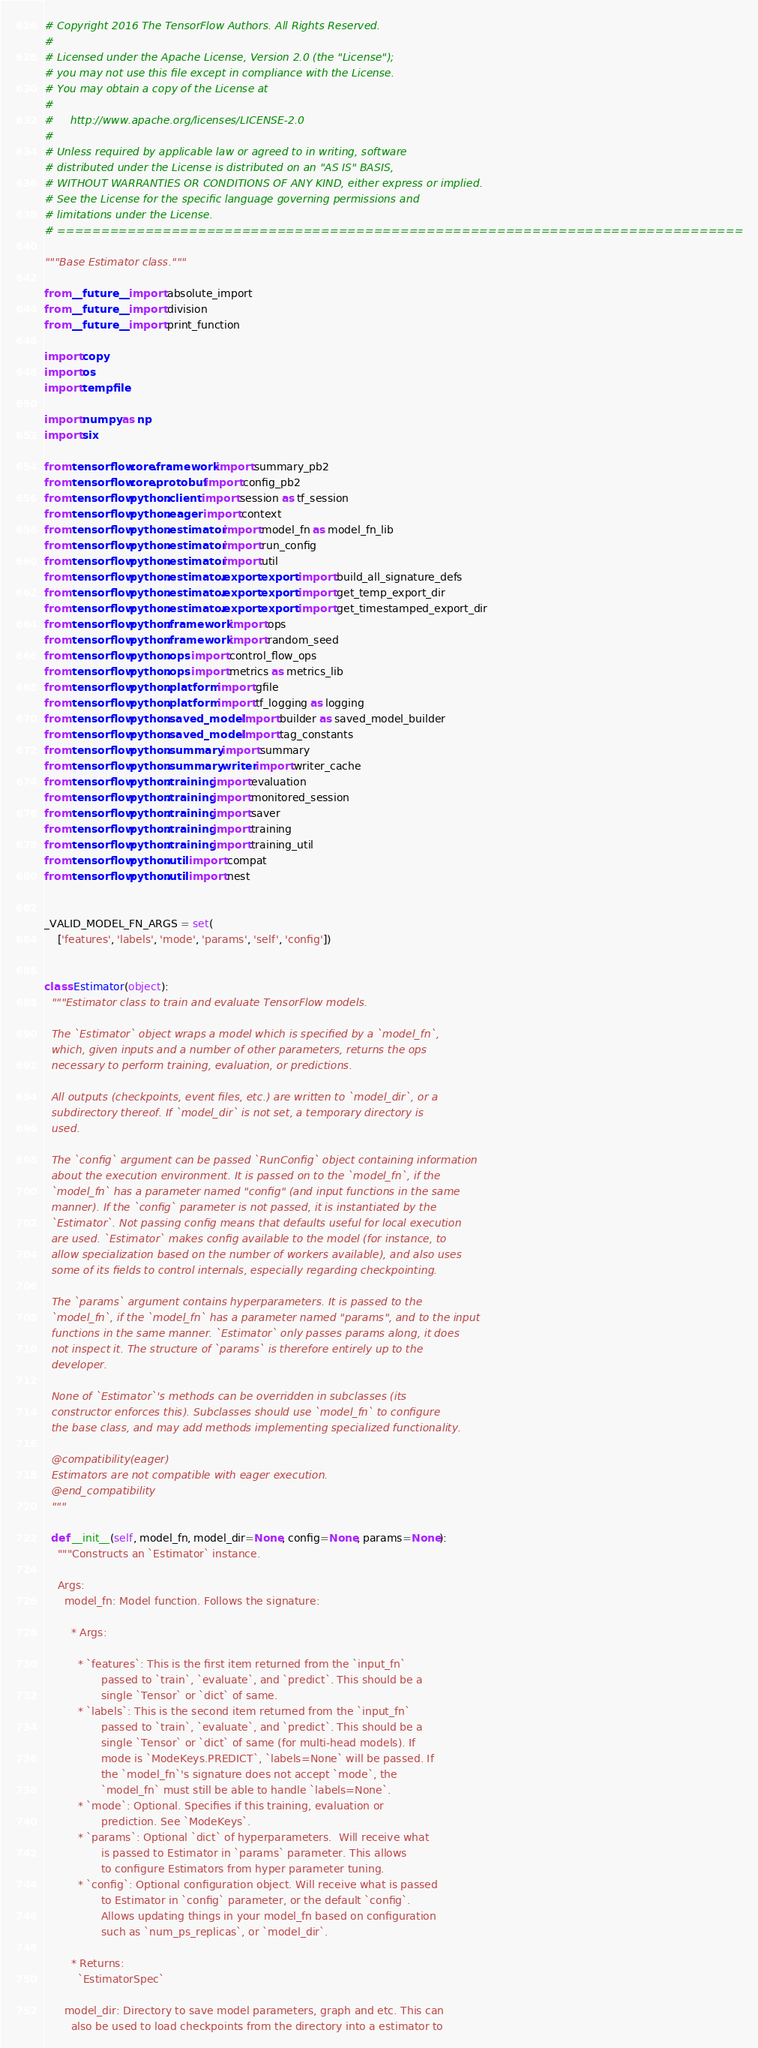<code> <loc_0><loc_0><loc_500><loc_500><_Python_># Copyright 2016 The TensorFlow Authors. All Rights Reserved.
#
# Licensed under the Apache License, Version 2.0 (the "License");
# you may not use this file except in compliance with the License.
# You may obtain a copy of the License at
#
#     http://www.apache.org/licenses/LICENSE-2.0
#
# Unless required by applicable law or agreed to in writing, software
# distributed under the License is distributed on an "AS IS" BASIS,
# WITHOUT WARRANTIES OR CONDITIONS OF ANY KIND, either express or implied.
# See the License for the specific language governing permissions and
# limitations under the License.
# ==============================================================================

"""Base Estimator class."""

from __future__ import absolute_import
from __future__ import division
from __future__ import print_function

import copy
import os
import tempfile

import numpy as np
import six

from tensorflow.core.framework import summary_pb2
from tensorflow.core.protobuf import config_pb2
from tensorflow.python.client import session as tf_session
from tensorflow.python.eager import context
from tensorflow.python.estimator import model_fn as model_fn_lib
from tensorflow.python.estimator import run_config
from tensorflow.python.estimator import util
from tensorflow.python.estimator.export.export import build_all_signature_defs
from tensorflow.python.estimator.export.export import get_temp_export_dir
from tensorflow.python.estimator.export.export import get_timestamped_export_dir
from tensorflow.python.framework import ops
from tensorflow.python.framework import random_seed
from tensorflow.python.ops import control_flow_ops
from tensorflow.python.ops import metrics as metrics_lib
from tensorflow.python.platform import gfile
from tensorflow.python.platform import tf_logging as logging
from tensorflow.python.saved_model import builder as saved_model_builder
from tensorflow.python.saved_model import tag_constants
from tensorflow.python.summary import summary
from tensorflow.python.summary.writer import writer_cache
from tensorflow.python.training import evaluation
from tensorflow.python.training import monitored_session
from tensorflow.python.training import saver
from tensorflow.python.training import training
from tensorflow.python.training import training_util
from tensorflow.python.util import compat
from tensorflow.python.util import nest


_VALID_MODEL_FN_ARGS = set(
    ['features', 'labels', 'mode', 'params', 'self', 'config'])


class Estimator(object):
  """Estimator class to train and evaluate TensorFlow models.

  The `Estimator` object wraps a model which is specified by a `model_fn`,
  which, given inputs and a number of other parameters, returns the ops
  necessary to perform training, evaluation, or predictions.

  All outputs (checkpoints, event files, etc.) are written to `model_dir`, or a
  subdirectory thereof. If `model_dir` is not set, a temporary directory is
  used.

  The `config` argument can be passed `RunConfig` object containing information
  about the execution environment. It is passed on to the `model_fn`, if the
  `model_fn` has a parameter named "config" (and input functions in the same
  manner). If the `config` parameter is not passed, it is instantiated by the
  `Estimator`. Not passing config means that defaults useful for local execution
  are used. `Estimator` makes config available to the model (for instance, to
  allow specialization based on the number of workers available), and also uses
  some of its fields to control internals, especially regarding checkpointing.

  The `params` argument contains hyperparameters. It is passed to the
  `model_fn`, if the `model_fn` has a parameter named "params", and to the input
  functions in the same manner. `Estimator` only passes params along, it does
  not inspect it. The structure of `params` is therefore entirely up to the
  developer.

  None of `Estimator`'s methods can be overridden in subclasses (its
  constructor enforces this). Subclasses should use `model_fn` to configure
  the base class, and may add methods implementing specialized functionality.

  @compatibility(eager)
  Estimators are not compatible with eager execution.
  @end_compatibility
  """

  def __init__(self, model_fn, model_dir=None, config=None, params=None):
    """Constructs an `Estimator` instance.

    Args:
      model_fn: Model function. Follows the signature:

        * Args:

          * `features`: This is the first item returned from the `input_fn`
                 passed to `train`, `evaluate`, and `predict`. This should be a
                 single `Tensor` or `dict` of same.
          * `labels`: This is the second item returned from the `input_fn`
                 passed to `train`, `evaluate`, and `predict`. This should be a
                 single `Tensor` or `dict` of same (for multi-head models). If
                 mode is `ModeKeys.PREDICT`, `labels=None` will be passed. If
                 the `model_fn`'s signature does not accept `mode`, the
                 `model_fn` must still be able to handle `labels=None`.
          * `mode`: Optional. Specifies if this training, evaluation or
                 prediction. See `ModeKeys`.
          * `params`: Optional `dict` of hyperparameters.  Will receive what
                 is passed to Estimator in `params` parameter. This allows
                 to configure Estimators from hyper parameter tuning.
          * `config`: Optional configuration object. Will receive what is passed
                 to Estimator in `config` parameter, or the default `config`.
                 Allows updating things in your model_fn based on configuration
                 such as `num_ps_replicas`, or `model_dir`.

        * Returns:
          `EstimatorSpec`

      model_dir: Directory to save model parameters, graph and etc. This can
        also be used to load checkpoints from the directory into a estimator to</code> 